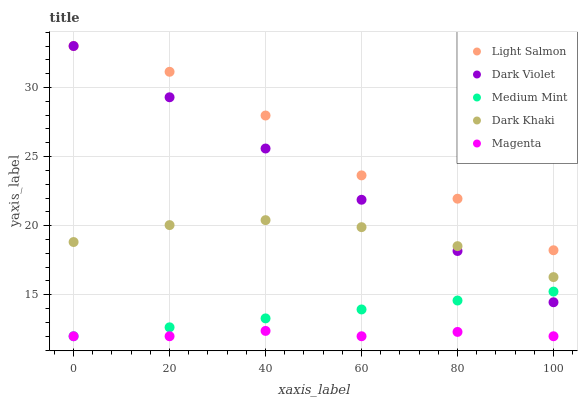Does Magenta have the minimum area under the curve?
Answer yes or no. Yes. Does Light Salmon have the maximum area under the curve?
Answer yes or no. Yes. Does Dark Khaki have the minimum area under the curve?
Answer yes or no. No. Does Dark Khaki have the maximum area under the curve?
Answer yes or no. No. Is Dark Violet the smoothest?
Answer yes or no. Yes. Is Light Salmon the roughest?
Answer yes or no. Yes. Is Dark Khaki the smoothest?
Answer yes or no. No. Is Dark Khaki the roughest?
Answer yes or no. No. Does Medium Mint have the lowest value?
Answer yes or no. Yes. Does Dark Khaki have the lowest value?
Answer yes or no. No. Does Dark Violet have the highest value?
Answer yes or no. Yes. Does Dark Khaki have the highest value?
Answer yes or no. No. Is Medium Mint less than Light Salmon?
Answer yes or no. Yes. Is Light Salmon greater than Medium Mint?
Answer yes or no. Yes. Does Light Salmon intersect Dark Violet?
Answer yes or no. Yes. Is Light Salmon less than Dark Violet?
Answer yes or no. No. Is Light Salmon greater than Dark Violet?
Answer yes or no. No. Does Medium Mint intersect Light Salmon?
Answer yes or no. No. 